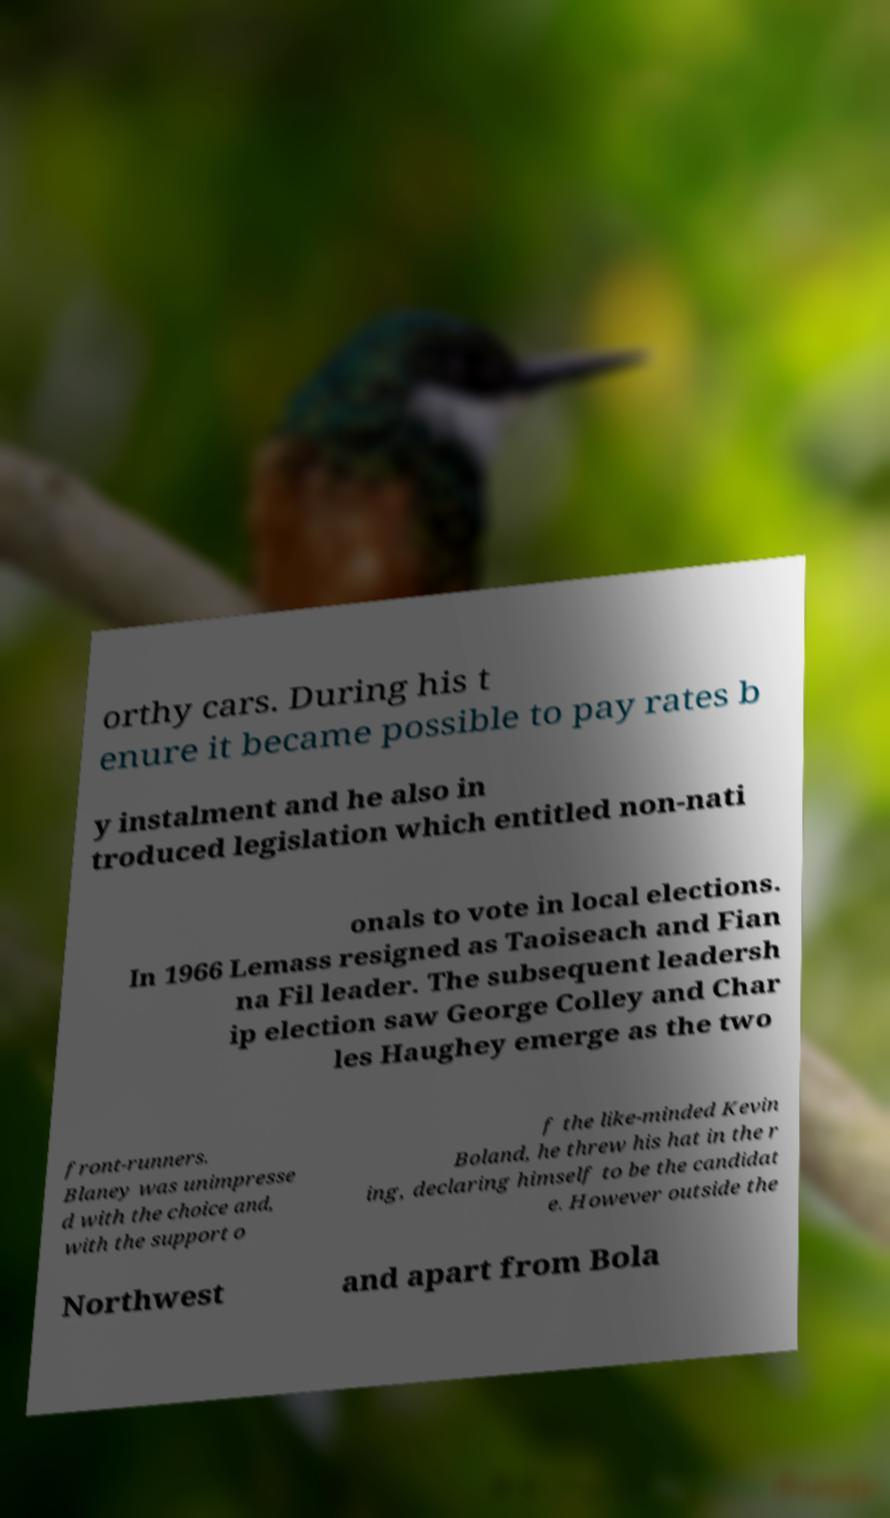Could you assist in decoding the text presented in this image and type it out clearly? orthy cars. During his t enure it became possible to pay rates b y instalment and he also in troduced legislation which entitled non-nati onals to vote in local elections. In 1966 Lemass resigned as Taoiseach and Fian na Fil leader. The subsequent leadersh ip election saw George Colley and Char les Haughey emerge as the two front-runners. Blaney was unimpresse d with the choice and, with the support o f the like-minded Kevin Boland, he threw his hat in the r ing, declaring himself to be the candidat e. However outside the Northwest and apart from Bola 